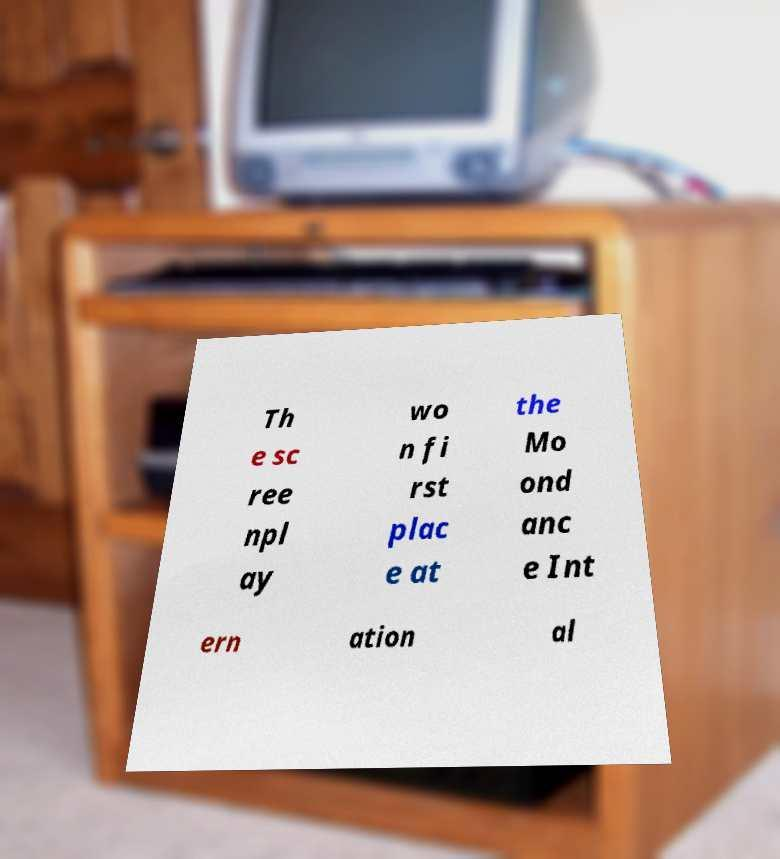Can you accurately transcribe the text from the provided image for me? Th e sc ree npl ay wo n fi rst plac e at the Mo ond anc e Int ern ation al 